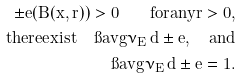Convert formula to latex. <formula><loc_0><loc_0><loc_500><loc_500>\pm e ( B ( x , r ) ) > 0 \quad f o r a n y r > 0 , \\ t h e r e e x i s t \quad \i a v g \nu _ { E } \, d \pm e , \quad a n d \\ \i a v g \nu _ { E } \, d \pm e = 1 .</formula> 